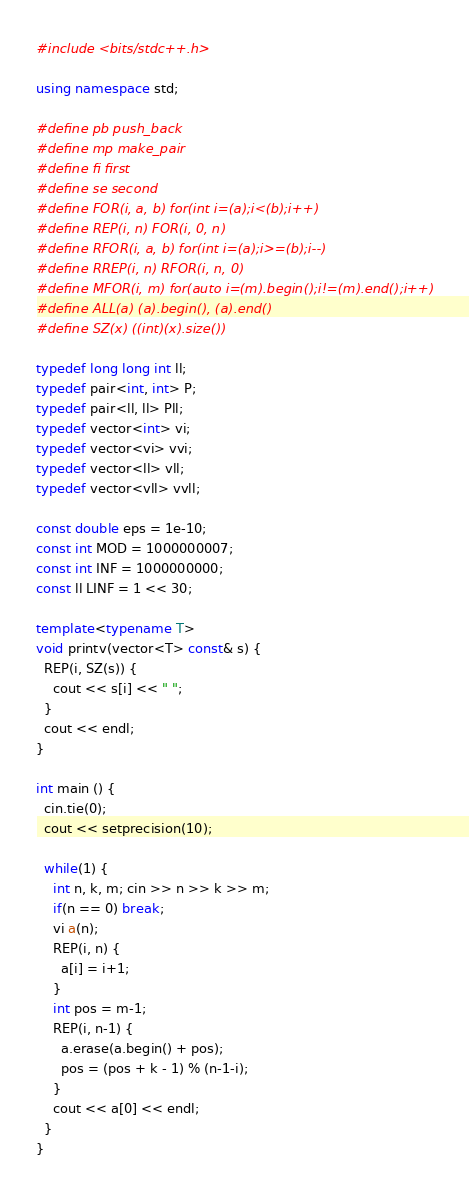Convert code to text. <code><loc_0><loc_0><loc_500><loc_500><_C++_>#include <bits/stdc++.h>

using namespace std;

#define pb push_back
#define mp make_pair
#define fi first
#define se second
#define FOR(i, a, b) for(int i=(a);i<(b);i++)
#define REP(i, n) FOR(i, 0, n)
#define RFOR(i, a, b) for(int i=(a);i>=(b);i--)
#define RREP(i, n) RFOR(i, n, 0)
#define MFOR(i, m) for(auto i=(m).begin();i!=(m).end();i++)
#define ALL(a) (a).begin(), (a).end()
#define SZ(x) ((int)(x).size())

typedef long long int ll;
typedef pair<int, int> P;
typedef pair<ll, ll> Pll;
typedef vector<int> vi;
typedef vector<vi> vvi;
typedef vector<ll> vll;
typedef vector<vll> vvll;

const double eps = 1e-10;
const int MOD = 1000000007;
const int INF = 1000000000;
const ll LINF = 1 << 30;

template<typename T>
void printv(vector<T> const& s) {
  REP(i, SZ(s)) {
    cout << s[i] << " ";
  }
  cout << endl;
}

int main () {
  cin.tie(0);
  cout << setprecision(10);

  while(1) {
    int n, k, m; cin >> n >> k >> m;
    if(n == 0) break;
    vi a(n);
    REP(i, n) {
      a[i] = i+1;
    }
    int pos = m-1;
    REP(i, n-1) {
      a.erase(a.begin() + pos);
      pos = (pos + k - 1) % (n-1-i);
    }
    cout << a[0] << endl;
  }
}

</code> 